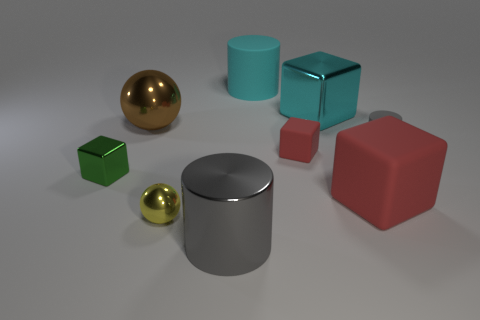What is the material of the big cyan object that is the same shape as the tiny green shiny object?
Provide a short and direct response. Metal. Is there anything else that has the same color as the big metal ball?
Make the answer very short. No. How many cylinders are either big rubber things or small yellow things?
Provide a short and direct response. 1. What number of things are both behind the large shiny block and to the left of the large cyan matte thing?
Offer a very short reply. 0. Are there the same number of tiny red things that are left of the green object and big cubes behind the brown metallic sphere?
Provide a succinct answer. No. Does the red object that is left of the large red matte object have the same shape as the green shiny object?
Provide a succinct answer. Yes. What shape is the small shiny thing in front of the large matte object right of the large block behind the gray matte cylinder?
Your answer should be very brief. Sphere. The big thing that is the same color as the tiny matte cube is what shape?
Provide a succinct answer. Cube. The object that is both behind the green metallic object and left of the big gray metallic thing is made of what material?
Your response must be concise. Metal. Are there fewer green objects than small brown spheres?
Offer a terse response. No. 